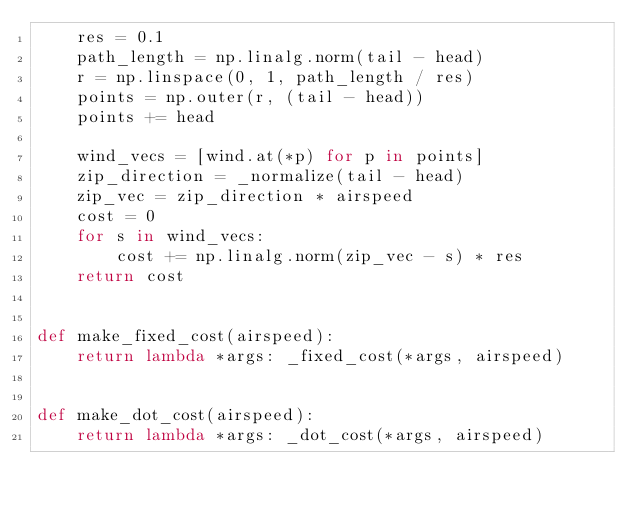<code> <loc_0><loc_0><loc_500><loc_500><_Python_>    res = 0.1
    path_length = np.linalg.norm(tail - head)
    r = np.linspace(0, 1, path_length / res)
    points = np.outer(r, (tail - head))
    points += head

    wind_vecs = [wind.at(*p) for p in points]
    zip_direction = _normalize(tail - head)
    zip_vec = zip_direction * airspeed
    cost = 0
    for s in wind_vecs:
        cost += np.linalg.norm(zip_vec - s) * res
    return cost


def make_fixed_cost(airspeed):
    return lambda *args: _fixed_cost(*args, airspeed)


def make_dot_cost(airspeed):
    return lambda *args: _dot_cost(*args, airspeed)
</code> 